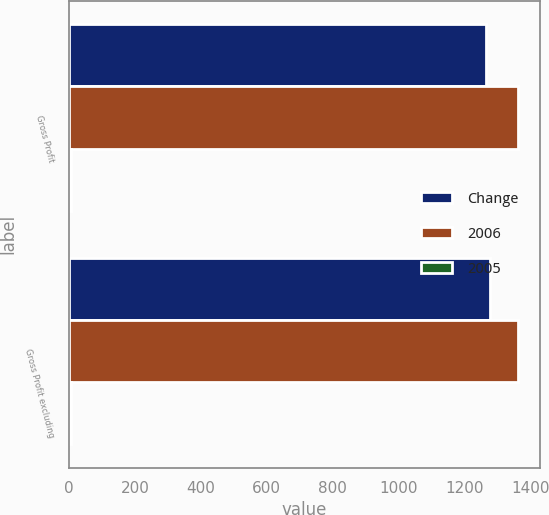Convert chart to OTSL. <chart><loc_0><loc_0><loc_500><loc_500><stacked_bar_chart><ecel><fcel>Gross Profit<fcel>Gross Profit excluding<nl><fcel>Change<fcel>1265<fcel>1275<nl><fcel>2006<fcel>1360<fcel>1360<nl><fcel>2005<fcel>7<fcel>6<nl></chart> 